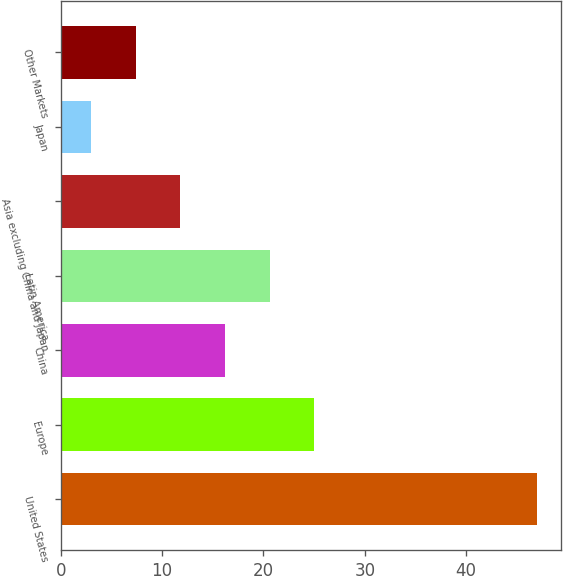Convert chart. <chart><loc_0><loc_0><loc_500><loc_500><bar_chart><fcel>United States<fcel>Europe<fcel>China<fcel>Latin America<fcel>Asia excluding China and Japan<fcel>Japan<fcel>Other Markets<nl><fcel>47<fcel>25<fcel>16.2<fcel>20.6<fcel>11.8<fcel>3<fcel>7.4<nl></chart> 